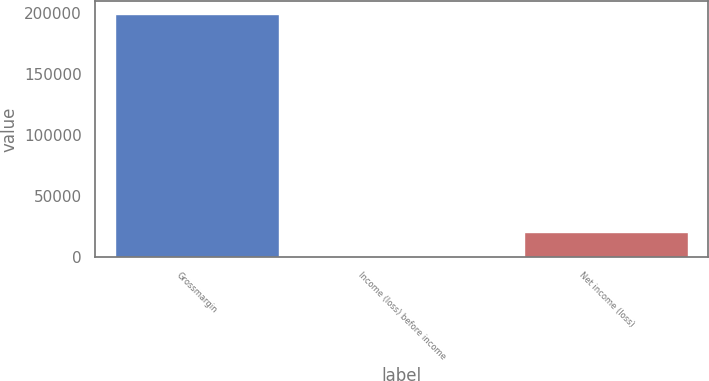Convert chart to OTSL. <chart><loc_0><loc_0><loc_500><loc_500><bar_chart><fcel>Grossmargin<fcel>Income (loss) before income<fcel>Net income (loss)<nl><fcel>199514<fcel>787<fcel>20659.7<nl></chart> 